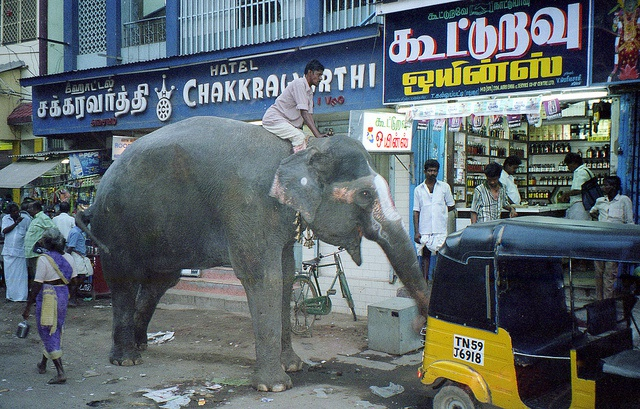Describe the objects in this image and their specific colors. I can see elephant in black, gray, and darkgray tones, car in black, olive, gray, and navy tones, people in black, gray, navy, and darkgray tones, bicycle in black, gray, darkgray, lightgray, and lightblue tones, and people in black, lightblue, and gray tones in this image. 